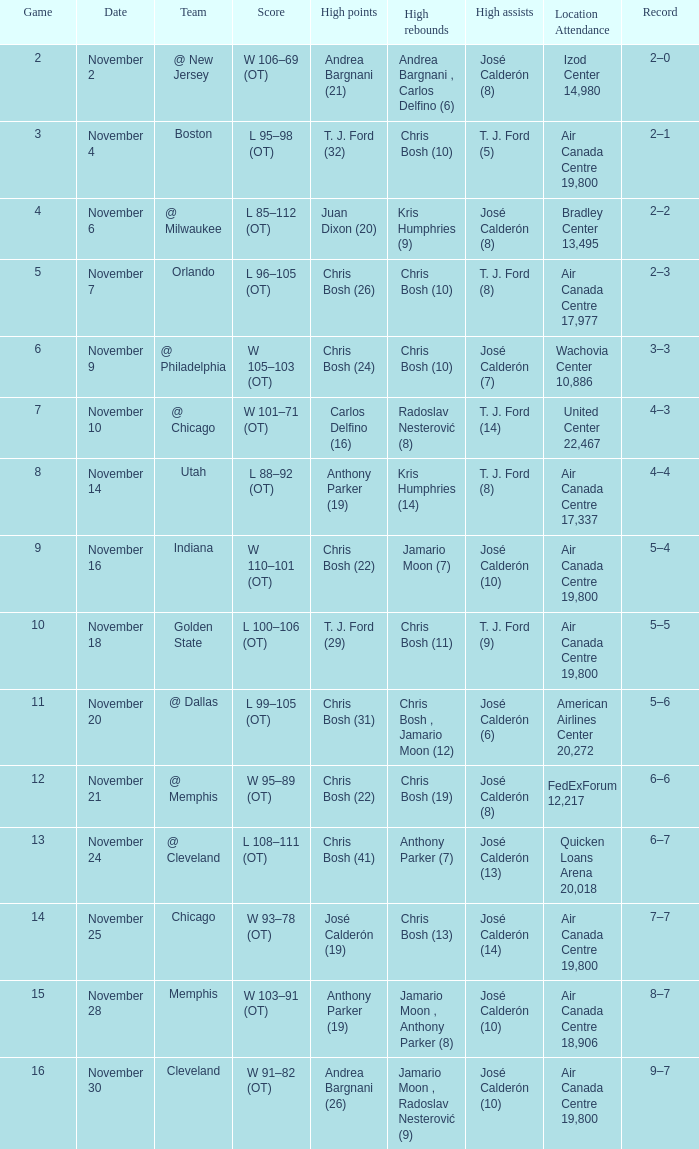When the team is at cleveland, what is their score? L 108–111 (OT). 